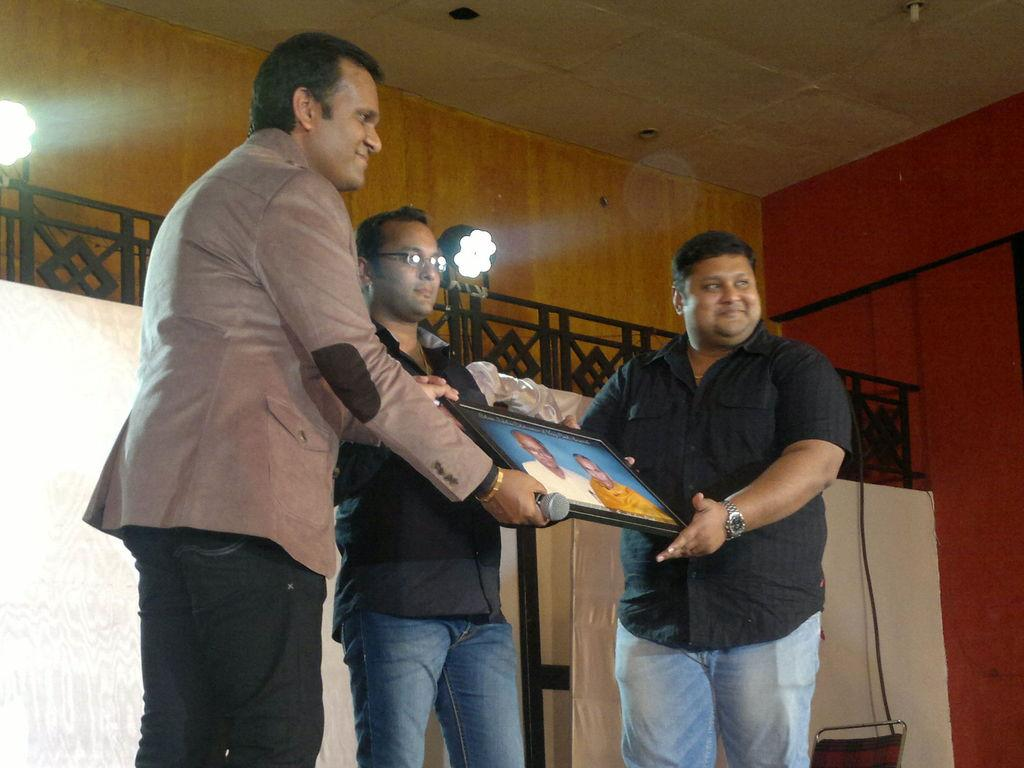How many men are in the image? There are men standing in the image, but the exact number is not specified. What is one of the men holding? One of the men is holding a photo frame. What can be seen in the background of the image? Walls, electric lights, and iron grills are visible in the background of the image. What type of ornament is hanging from the whistle in the image? There is no whistle or ornament present in the image. Can you tell me how many ants are crawling on the iron grills in the image? There are no ants visible in the image; only the men, photo frame, walls, electric lights, and iron grills are present. 